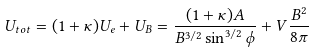<formula> <loc_0><loc_0><loc_500><loc_500>U _ { t o t } = ( 1 + \kappa ) U _ { e } + U _ { B } = \frac { ( 1 + \kappa ) A } { B ^ { 3 / 2 } \sin ^ { 3 / 2 } \phi } + V \frac { B ^ { 2 } } { 8 \pi }</formula> 